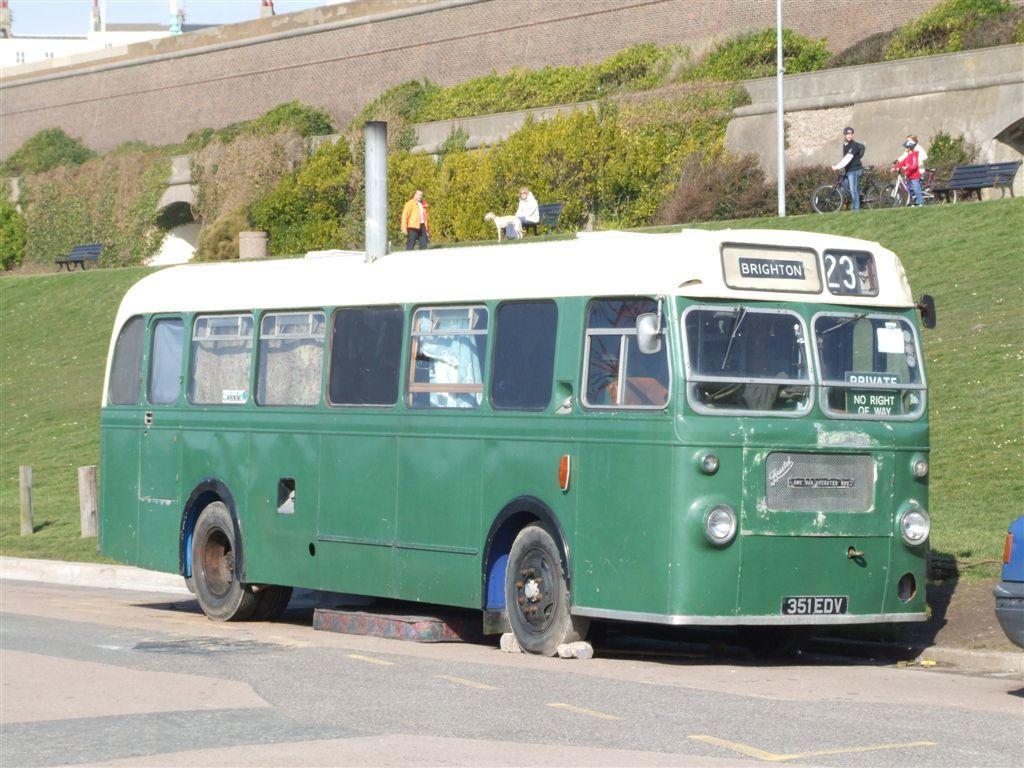What bus number is this?
Your response must be concise. 23. What city does the bus have written on it?
Offer a very short reply. Brighton. 